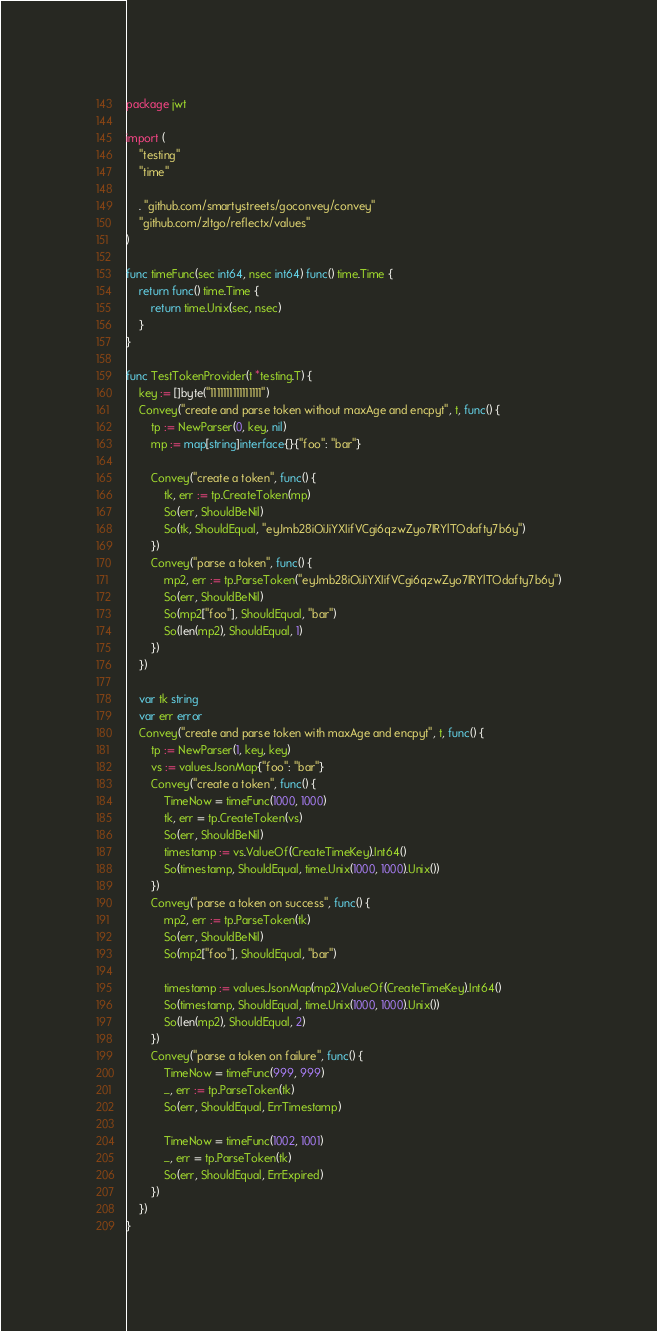Convert code to text. <code><loc_0><loc_0><loc_500><loc_500><_Go_>package jwt

import (
	"testing"
	"time"

	. "github.com/smartystreets/goconvey/convey"
	"github.com/zltgo/reflectx/values"
)

func timeFunc(sec int64, nsec int64) func() time.Time {
	return func() time.Time {
		return time.Unix(sec, nsec)
	}
}

func TestTokenProvider(t *testing.T) {
	key := []byte("1111111111111111")
	Convey("create and parse token without maxAge and encpyt", t, func() {
		tp := NewParser(0, key, nil)
		mp := map[string]interface{}{"foo": "bar"}

		Convey("create a token", func() {
			tk, err := tp.CreateToken(mp)
			So(err, ShouldBeNil)
			So(tk, ShouldEqual, "eyJmb28iOiJiYXIifVCgi6qzwZyo7IRYlTOdafty7b6y")
		})
		Convey("parse a token", func() {
			mp2, err := tp.ParseToken("eyJmb28iOiJiYXIifVCgi6qzwZyo7IRYlTOdafty7b6y")
			So(err, ShouldBeNil)
			So(mp2["foo"], ShouldEqual, "bar")
			So(len(mp2), ShouldEqual, 1)
		})
	})

	var tk string
	var err error
	Convey("create and parse token with maxAge and encpyt", t, func() {
		tp := NewParser(1, key, key)
		vs := values.JsonMap{"foo": "bar"}
		Convey("create a token", func() {
			TimeNow = timeFunc(1000, 1000)
			tk, err = tp.CreateToken(vs)
			So(err, ShouldBeNil)
			timestamp := vs.ValueOf(CreateTimeKey).Int64()
			So(timestamp, ShouldEqual, time.Unix(1000, 1000).Unix())
		})
		Convey("parse a token on success", func() {
			mp2, err := tp.ParseToken(tk)
			So(err, ShouldBeNil)
			So(mp2["foo"], ShouldEqual, "bar")

			timestamp := values.JsonMap(mp2).ValueOf(CreateTimeKey).Int64()
			So(timestamp, ShouldEqual, time.Unix(1000, 1000).Unix())
			So(len(mp2), ShouldEqual, 2)
		})
		Convey("parse a token on failure", func() {
			TimeNow = timeFunc(999, 999)
			_, err := tp.ParseToken(tk)
			So(err, ShouldEqual, ErrTimestamp)

			TimeNow = timeFunc(1002, 1001)
			_, err = tp.ParseToken(tk)
			So(err, ShouldEqual, ErrExpired)
		})
	})
}
</code> 